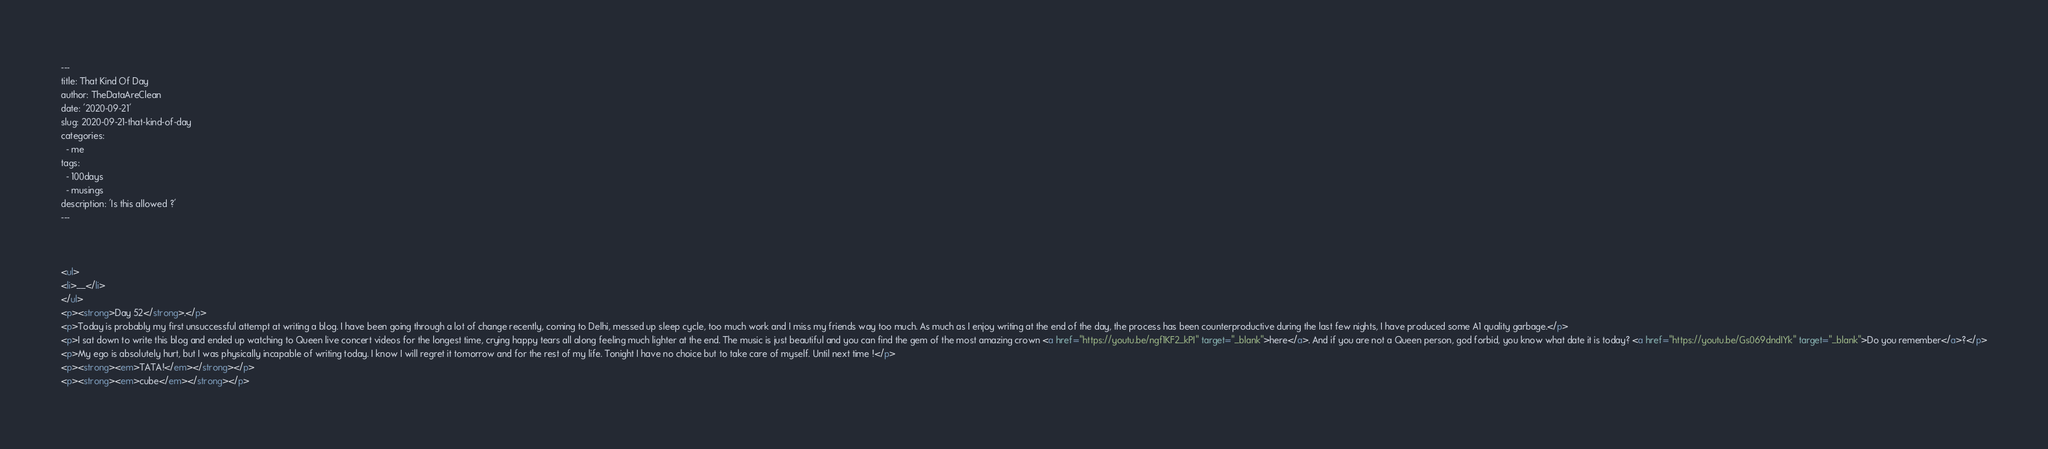Convert code to text. <code><loc_0><loc_0><loc_500><loc_500><_HTML_>---
title: That Kind Of Day
author: TheDataAreClean
date: '2020-09-21'
slug: 2020-09-21-that-kind-of-day
categories:
  - me
tags:
  - 100days
  - musings
description: 'Is this allowed ?'
---



<ul>
<li>__</li>
</ul>
<p><strong>Day 52</strong>.</p>
<p>Today is probably my first unsuccessful attempt at writing a blog. I have been going through a lot of change recently, coming to Delhi, messed up sleep cycle, too much work and I miss my friends way too much. As much as I enjoy writing at the end of the day, the process has been counterproductive during the last few nights, I have produced some A1 quality garbage.</p>
<p>I sat down to write this blog and ended up watching to Queen live concert videos for the longest time, crying happy tears all along feeling much lighter at the end. The music is just beautiful and you can find the gem of the most amazing crown <a href="https://youtu.be/ngf1KF2_kPI" target="_blank">here</a>. And if you are not a Queen person, god forbid, you know what date it is today? <a href="https://youtu.be/Gs069dndIYk" target="_blank">Do you remember</a>?</p>
<p>My ego is absolutely hurt, but I was physically incapable of writing today. I know I will regret it tomorrow and for the rest of my life. Tonight I have no choice but to take care of myself. Until next time !</p>
<p><strong><em>TATA!</em></strong></p>
<p><strong><em>cube</em></strong></p>
</code> 